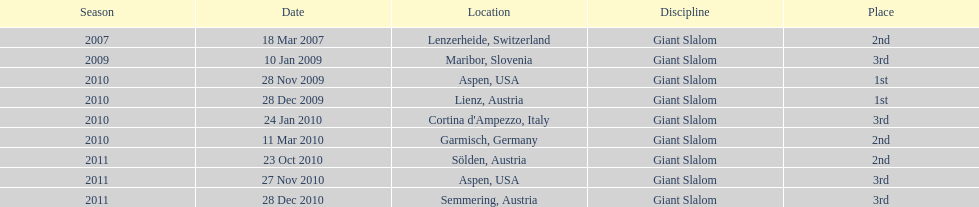If the final race's outcome wasn't the 1st place, which position did they finish in? 3rd. 